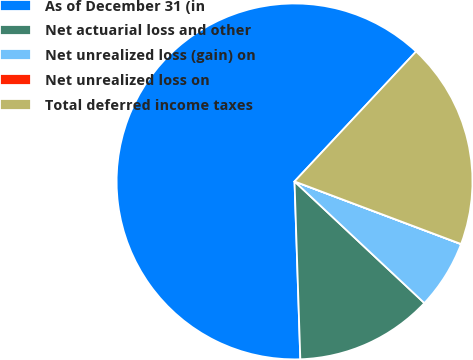<chart> <loc_0><loc_0><loc_500><loc_500><pie_chart><fcel>As of December 31 (in<fcel>Net actuarial loss and other<fcel>Net unrealized loss (gain) on<fcel>Net unrealized loss on<fcel>Total deferred income taxes<nl><fcel>62.49%<fcel>12.5%<fcel>6.25%<fcel>0.01%<fcel>18.75%<nl></chart> 